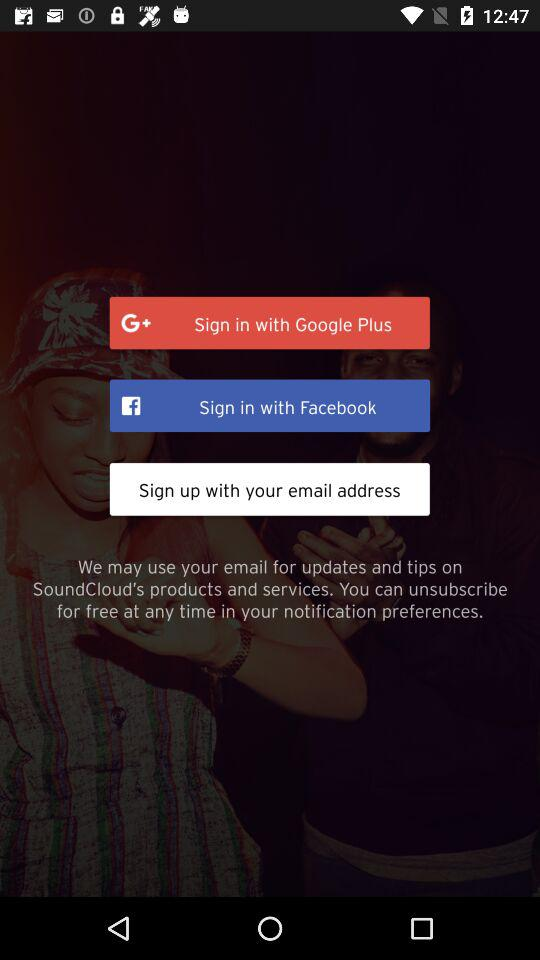What options are given for signing in? The options given for signing in are: "Sign in with Google Plus", "Sign in with Facebook", and "Sign up with your email address". 